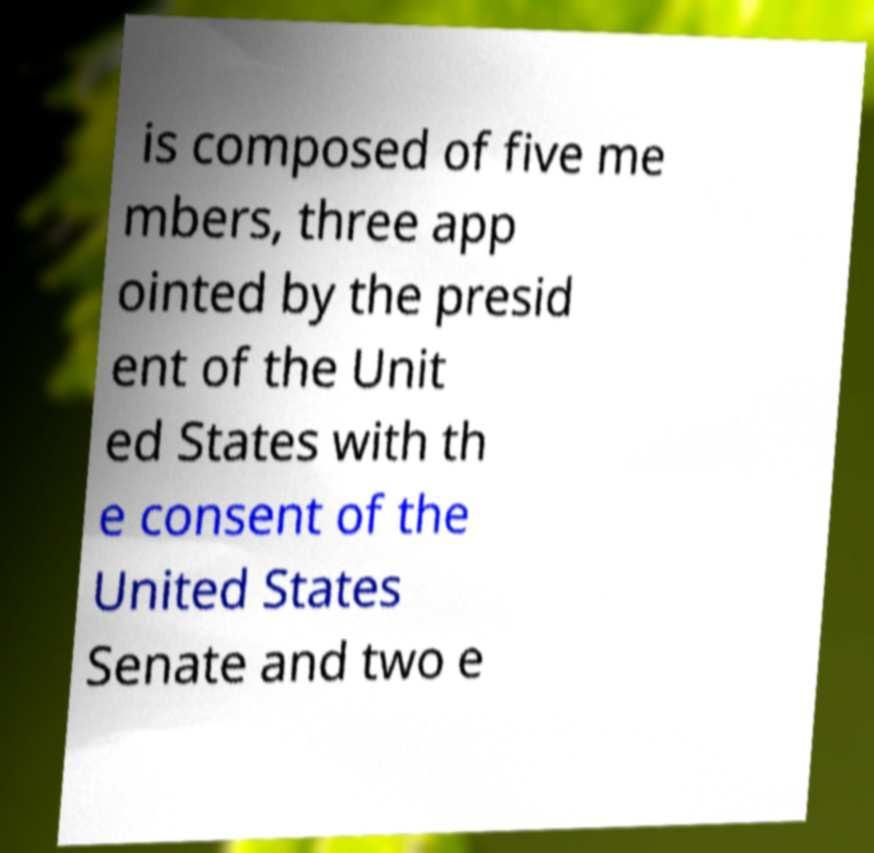For documentation purposes, I need the text within this image transcribed. Could you provide that? is composed of five me mbers, three app ointed by the presid ent of the Unit ed States with th e consent of the United States Senate and two e 